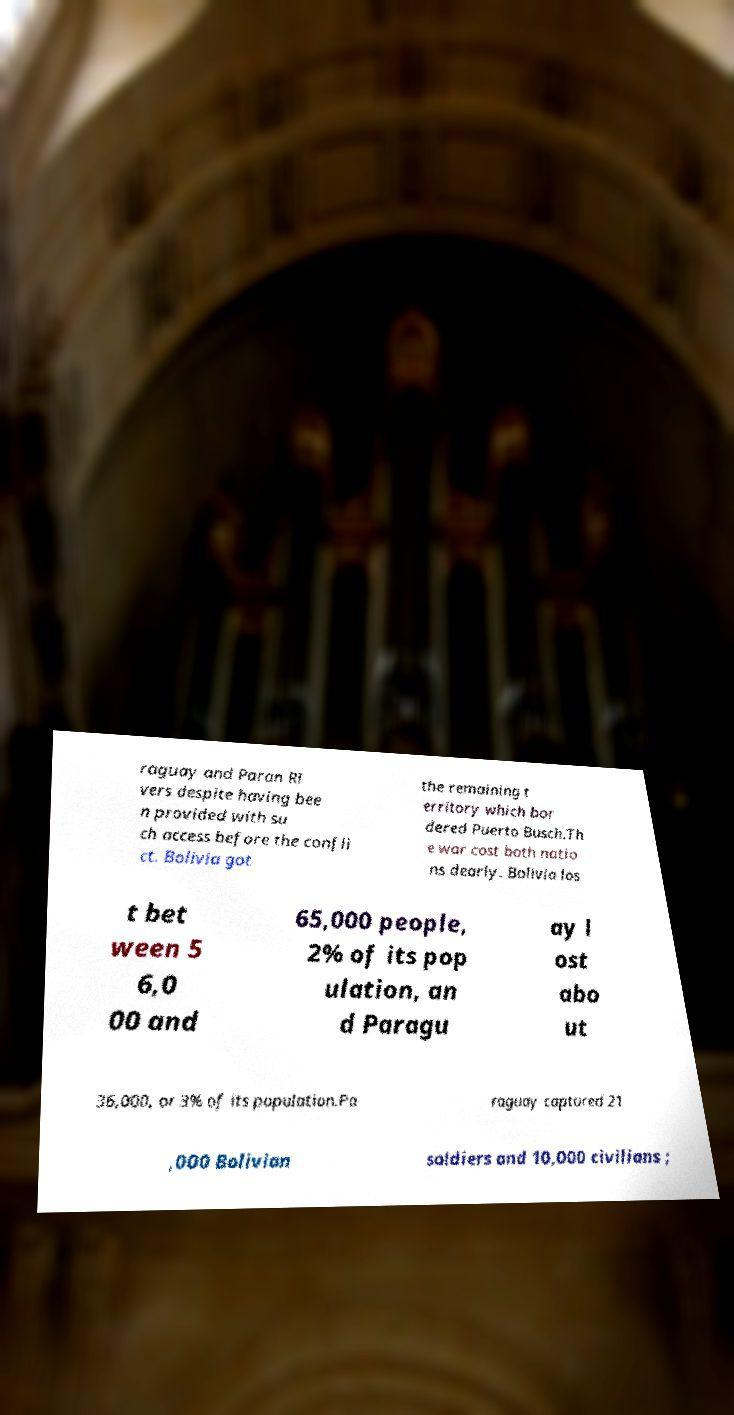Could you assist in decoding the text presented in this image and type it out clearly? raguay and Paran Ri vers despite having bee n provided with su ch access before the confli ct. Bolivia got the remaining t erritory which bor dered Puerto Busch.Th e war cost both natio ns dearly. Bolivia los t bet ween 5 6,0 00 and 65,000 people, 2% of its pop ulation, an d Paragu ay l ost abo ut 36,000, or 3% of its population.Pa raguay captured 21 ,000 Bolivian soldiers and 10,000 civilians ; 